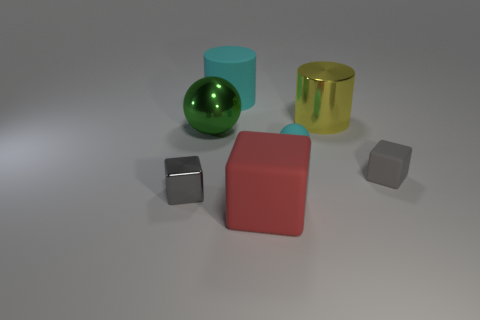Is the color of the shiny block the same as the object to the right of the shiny cylinder?
Your answer should be very brief. Yes. The gray object that is made of the same material as the cyan ball is what size?
Provide a succinct answer. Small. There is a matte sphere that is the same color as the rubber cylinder; what size is it?
Your response must be concise. Small. Is the big metal sphere the same color as the tiny shiny cube?
Provide a short and direct response. No. Is there a large metal cylinder to the left of the small block in front of the matte thing that is to the right of the big yellow metal object?
Ensure brevity in your answer.  No. What number of red rubber blocks have the same size as the green metal ball?
Your response must be concise. 1. Does the gray thing to the right of the small metal thing have the same size as the gray block that is left of the yellow cylinder?
Provide a short and direct response. Yes. What shape is the big object that is both in front of the shiny cylinder and on the left side of the large red matte object?
Give a very brief answer. Sphere. Is there a sphere that has the same color as the small shiny block?
Offer a terse response. No. Are any large green objects visible?
Your response must be concise. Yes. 